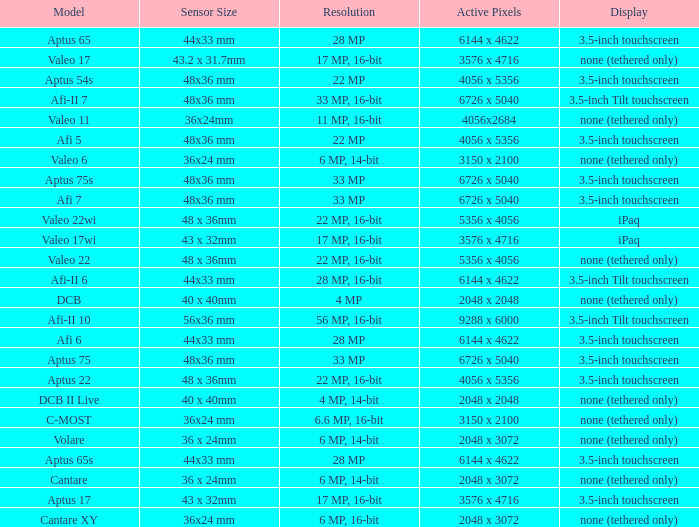What are the active pixels of the c-most model camera? 3150 x 2100. 